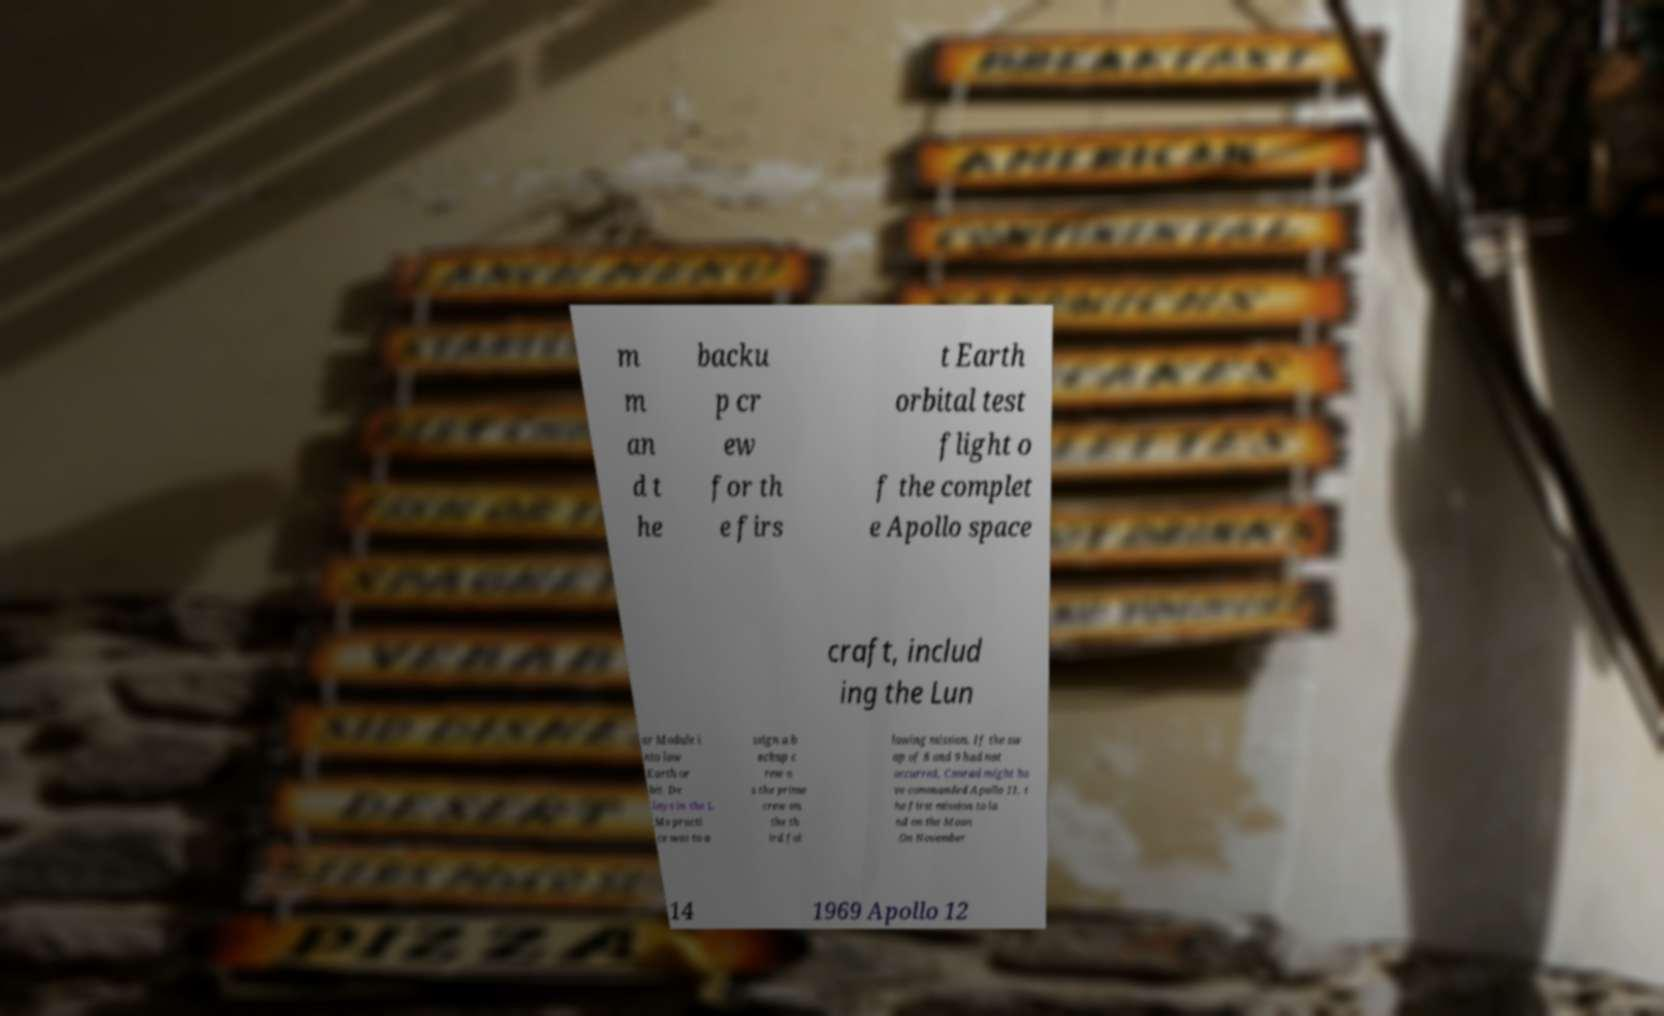Could you assist in decoding the text presented in this image and type it out clearly? m m an d t he backu p cr ew for th e firs t Earth orbital test flight o f the complet e Apollo space craft, includ ing the Lun ar Module i nto low Earth or bit. De lays in the L Ms practi ce was to a ssign a b ackup c rew a s the prime crew on the th ird fol lowing mission. If the sw ap of 8 and 9 had not occurred, Conrad might ha ve commanded Apollo 11, t he first mission to la nd on the Moon .On November 14 1969 Apollo 12 